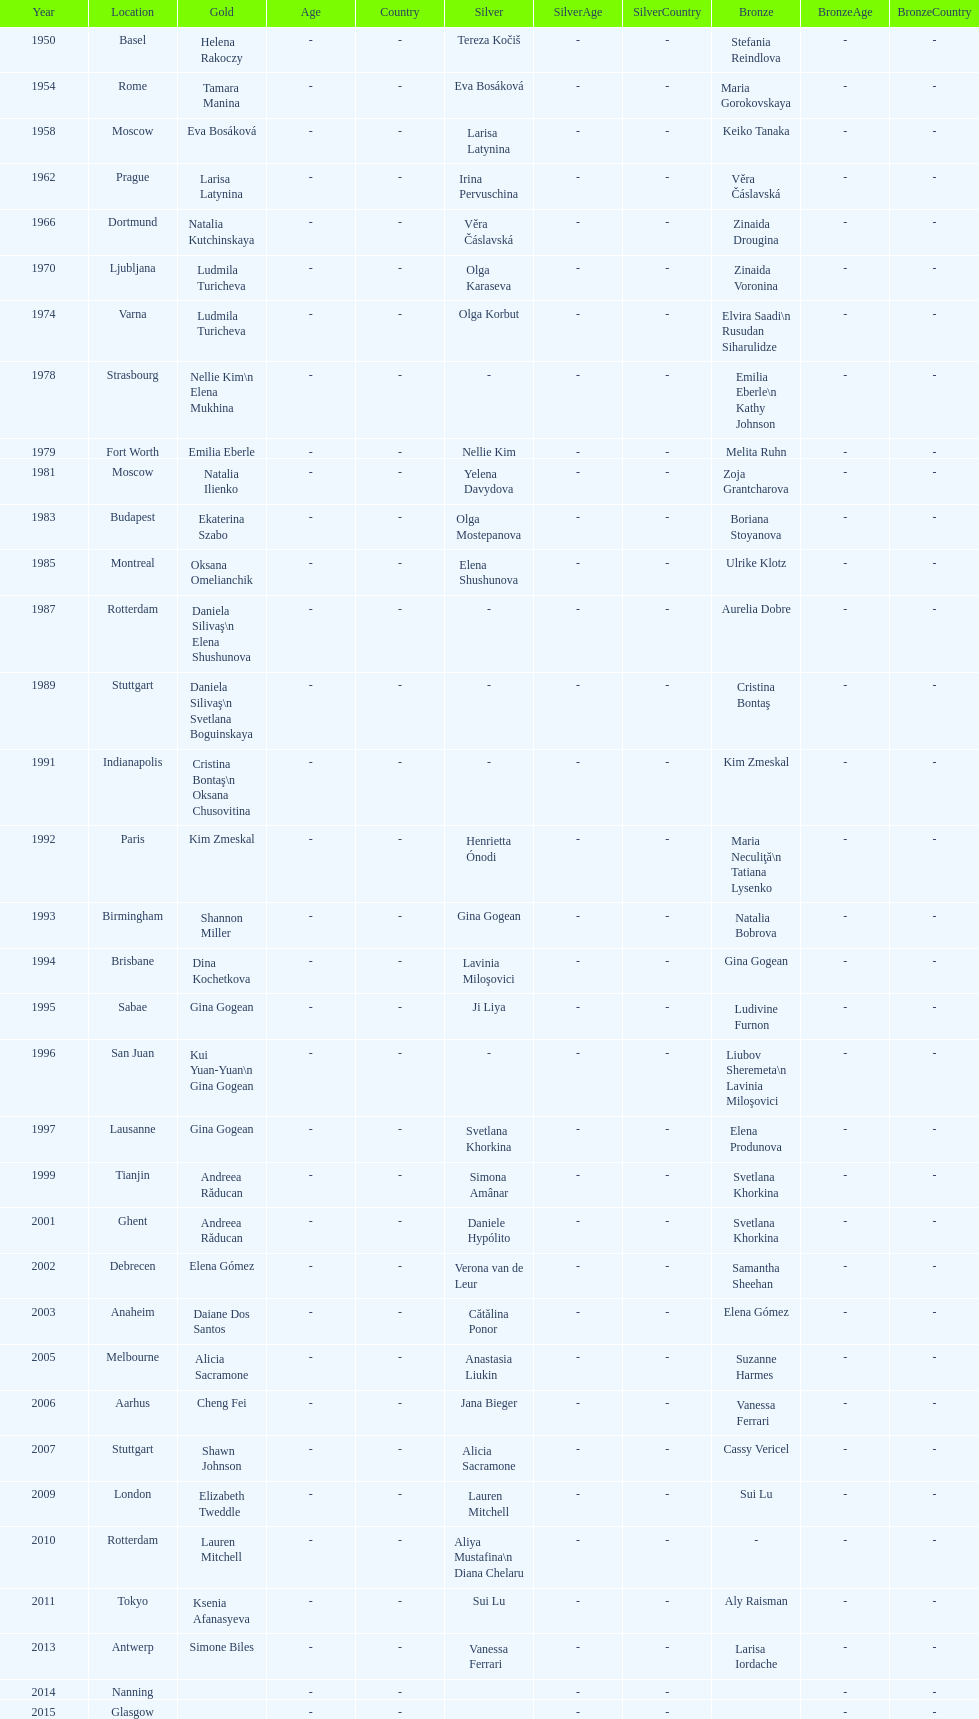How many times was the world artistic gymnastics championships held in the united states? 3. 